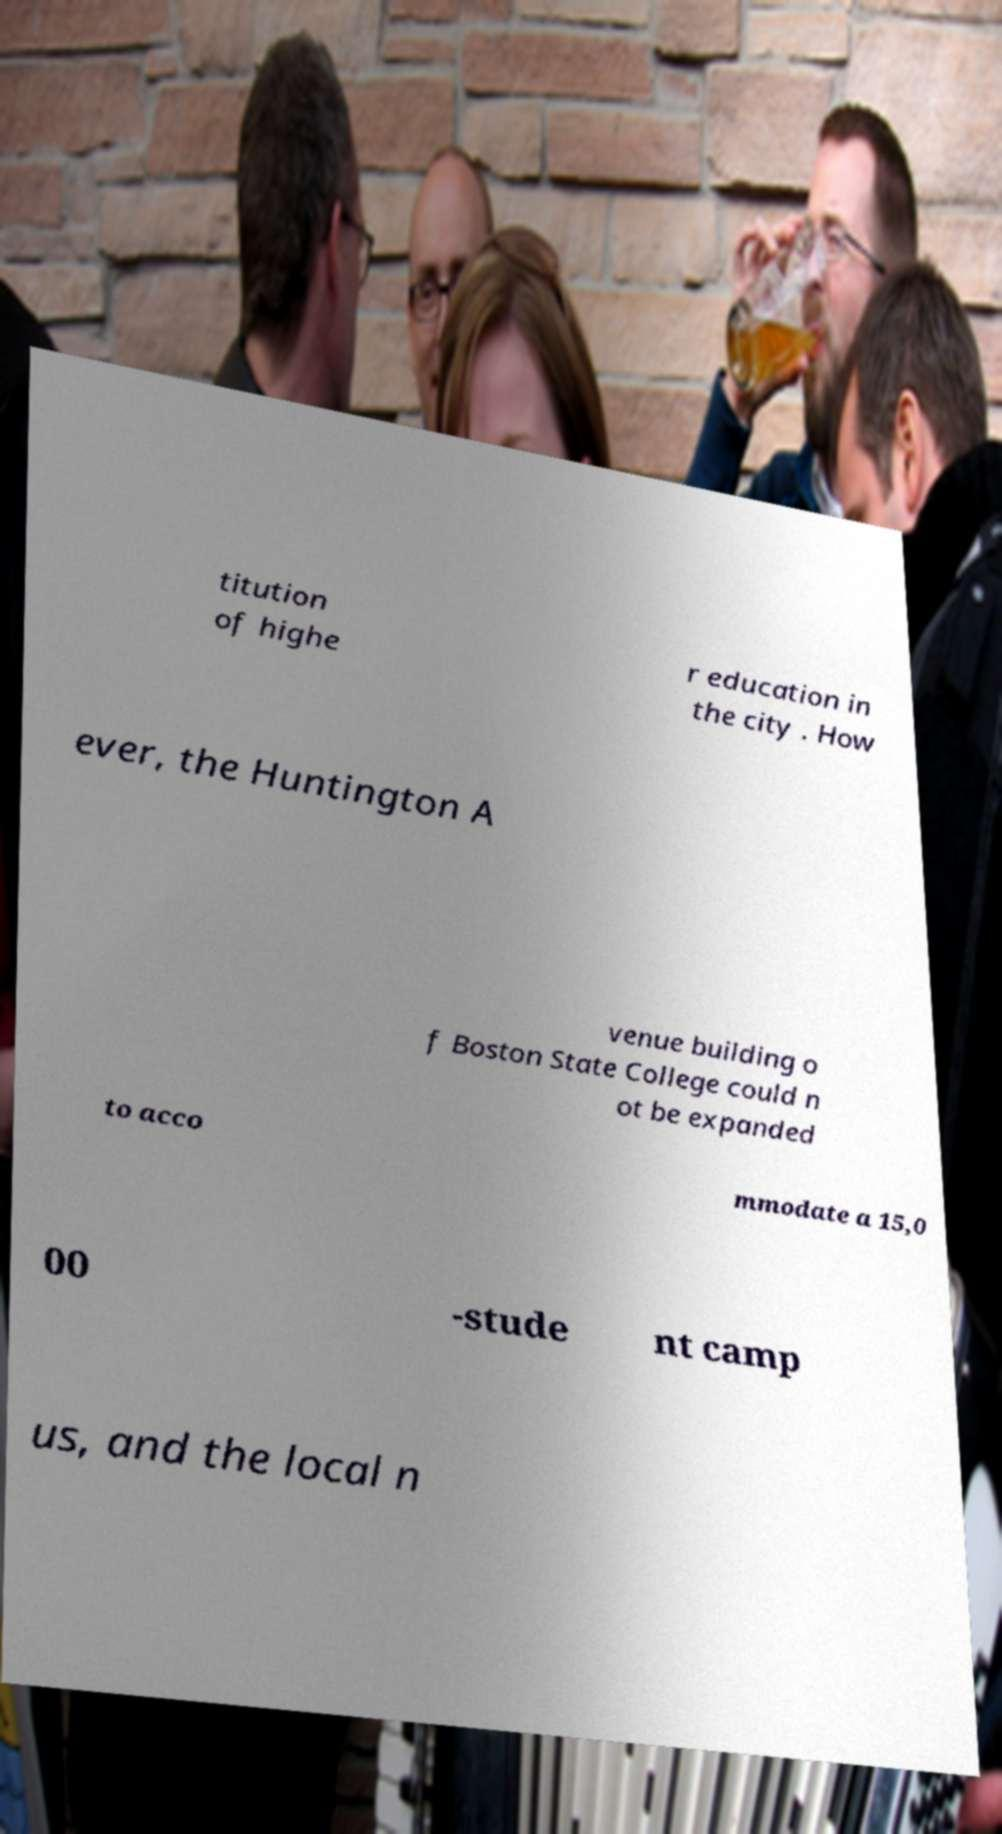Can you accurately transcribe the text from the provided image for me? titution of highe r education in the city . How ever, the Huntington A venue building o f Boston State College could n ot be expanded to acco mmodate a 15,0 00 -stude nt camp us, and the local n 